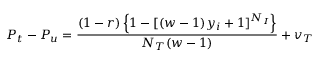Convert formula to latex. <formula><loc_0><loc_0><loc_500><loc_500>P _ { t } - P _ { u } = \frac { ( 1 - r ) \left \{ 1 - [ ( w - 1 ) y _ { i } + 1 ] ^ { N _ { I } } \right \} } { N _ { T } ( w - 1 ) } + v _ { T }</formula> 